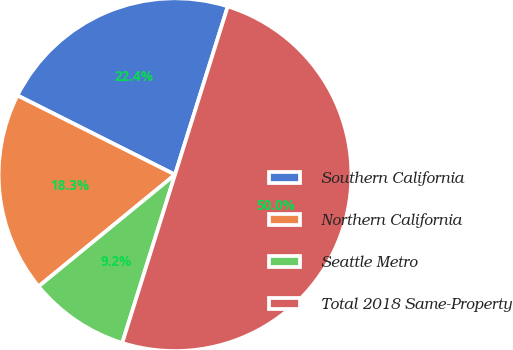Convert chart. <chart><loc_0><loc_0><loc_500><loc_500><pie_chart><fcel>Southern California<fcel>Northern California<fcel>Seattle Metro<fcel>Total 2018 Same-Property<nl><fcel>22.42%<fcel>18.34%<fcel>9.24%<fcel>50.0%<nl></chart> 